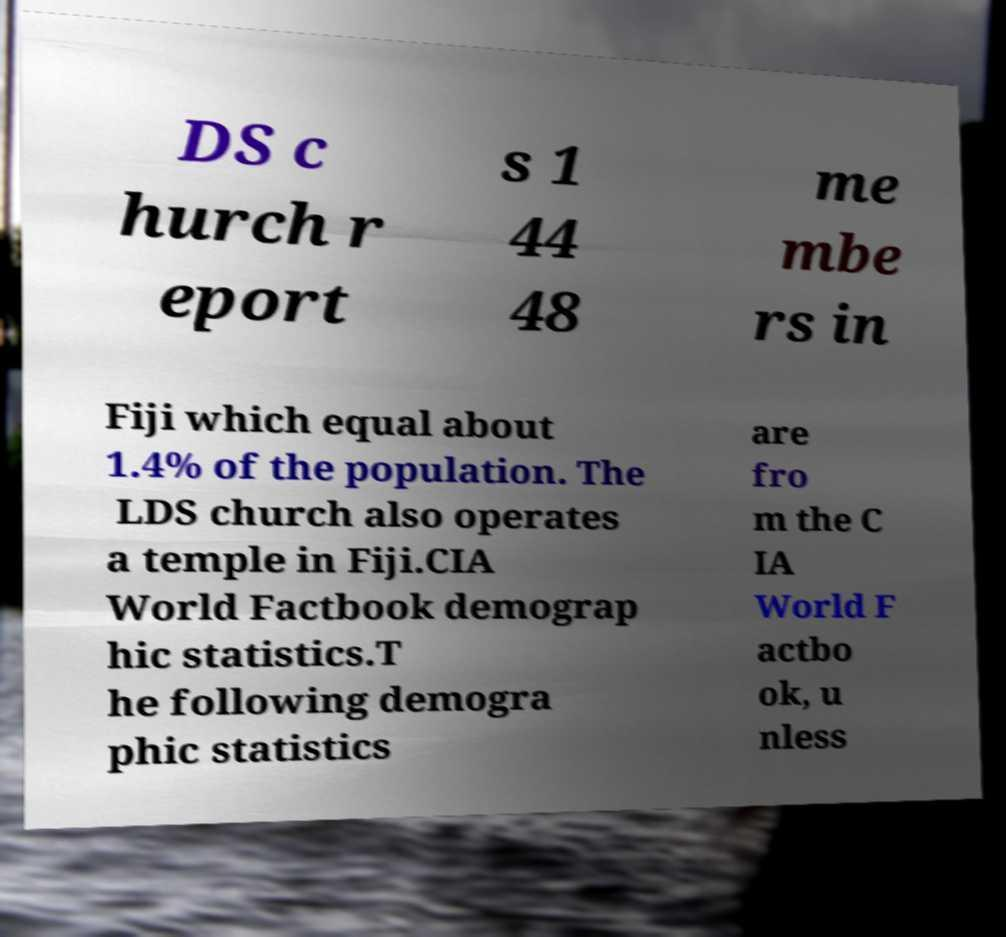Please read and relay the text visible in this image. What does it say? DS c hurch r eport s 1 44 48 me mbe rs in Fiji which equal about 1.4% of the population. The LDS church also operates a temple in Fiji.CIA World Factbook demograp hic statistics.T he following demogra phic statistics are fro m the C IA World F actbo ok, u nless 